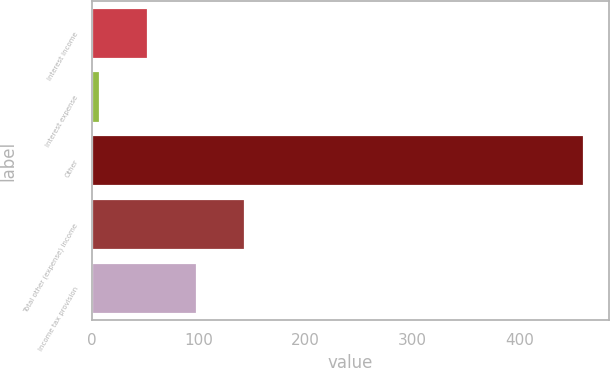Convert chart to OTSL. <chart><loc_0><loc_0><loc_500><loc_500><bar_chart><fcel>Interest income<fcel>Interest expense<fcel>Other<fcel>Total other (expense) income<fcel>Income tax provision<nl><fcel>52.4<fcel>7<fcel>461<fcel>143.2<fcel>97.8<nl></chart> 